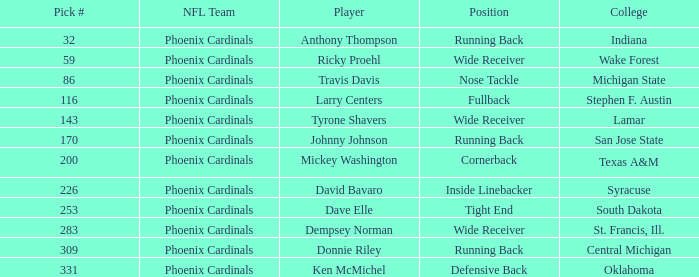Which NFL team has a pick# less than 200 for Travis Davis? Phoenix Cardinals. 